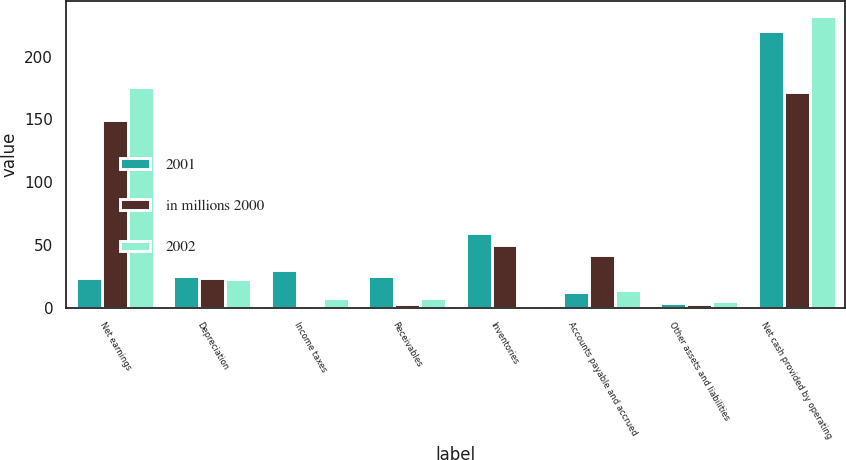Convert chart to OTSL. <chart><loc_0><loc_0><loc_500><loc_500><stacked_bar_chart><ecel><fcel>Net earnings<fcel>Depreciation<fcel>Income taxes<fcel>Receivables<fcel>Inventories<fcel>Accounts payable and accrued<fcel>Other assets and liabilities<fcel>Net cash provided by operating<nl><fcel>2001<fcel>23.4<fcel>25.3<fcel>29.9<fcel>25<fcel>59.7<fcel>12.2<fcel>4.1<fcel>220.2<nl><fcel>in millions 2000<fcel>149.8<fcel>23.4<fcel>1.1<fcel>2.6<fcel>50.2<fcel>41.9<fcel>3.2<fcel>171.8<nl><fcel>2002<fcel>176<fcel>23.1<fcel>7.8<fcel>7.8<fcel>2.1<fcel>14.5<fcel>5.3<fcel>232.4<nl></chart> 